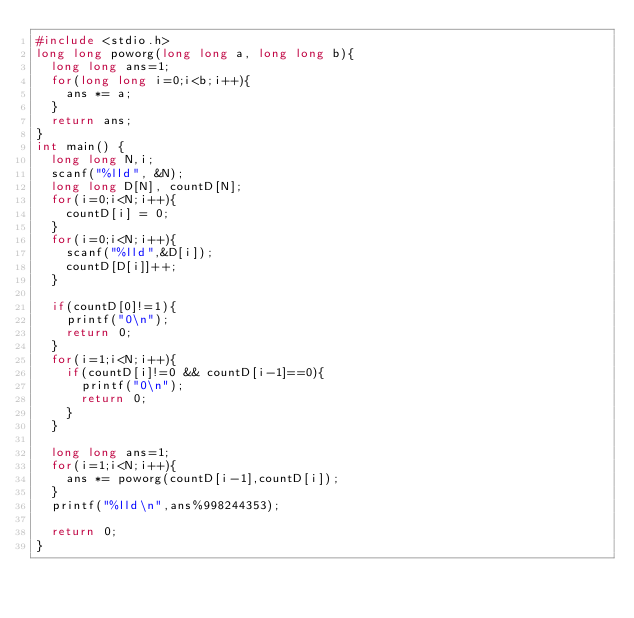Convert code to text. <code><loc_0><loc_0><loc_500><loc_500><_C_>#include <stdio.h>
long long poworg(long long a, long long b){
  long long ans=1;
  for(long long i=0;i<b;i++){
    ans *= a;
  }
  return ans;
}
int main() {
  long long N,i;
  scanf("%lld", &N);
  long long D[N], countD[N];
  for(i=0;i<N;i++){
    countD[i] = 0;
  }
  for(i=0;i<N;i++){
    scanf("%lld",&D[i]);
    countD[D[i]]++;
  }

  if(countD[0]!=1){
    printf("0\n");
    return 0;
  }
  for(i=1;i<N;i++){
    if(countD[i]!=0 && countD[i-1]==0){
      printf("0\n");
      return 0;
    }
  }
  
  long long ans=1;
  for(i=1;i<N;i++){
    ans *= poworg(countD[i-1],countD[i]);
  }
  printf("%lld\n",ans%998244353);
  
  return 0;
}
</code> 